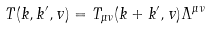<formula> <loc_0><loc_0><loc_500><loc_500>T ( k , k ^ { \prime } , v ) = T _ { \mu \nu } ( k + k ^ { \prime } , v ) \Lambda ^ { \mu \nu }</formula> 